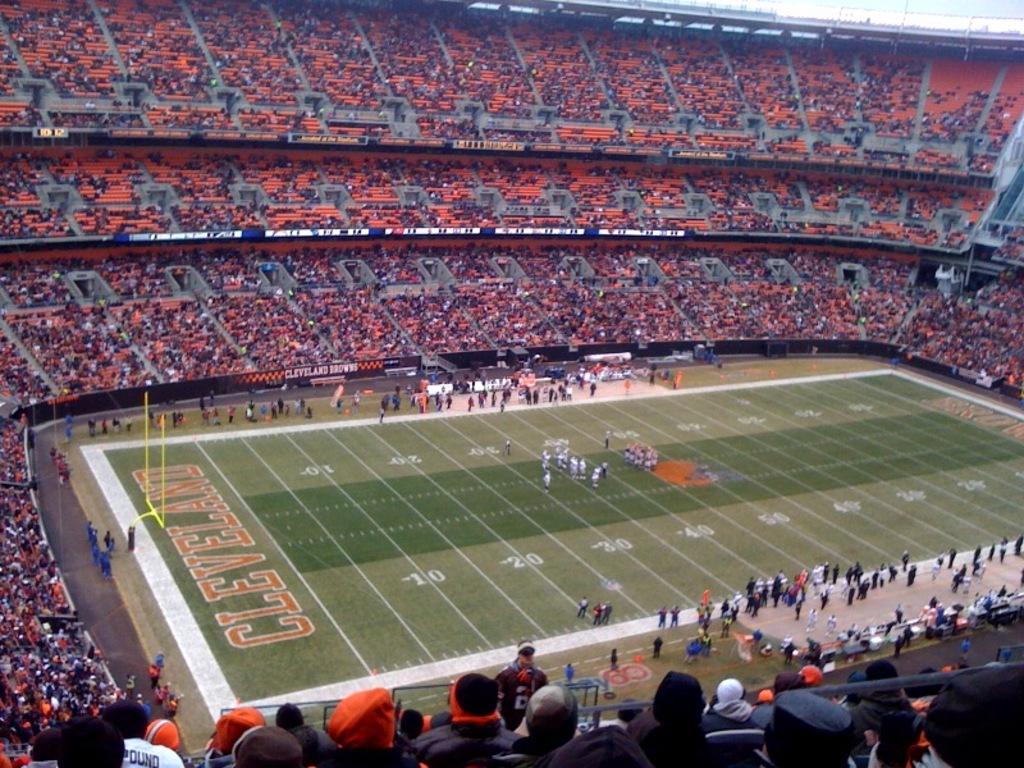What game are they about to watch?
Keep it short and to the point. Cleveland. What is the name of the football team wrote in the grass?
Give a very brief answer. Cleveland. 